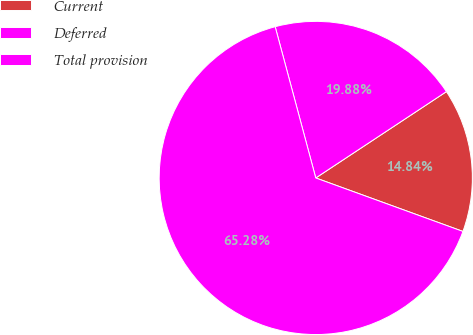Convert chart. <chart><loc_0><loc_0><loc_500><loc_500><pie_chart><fcel>Current<fcel>Deferred<fcel>Total provision<nl><fcel>14.84%<fcel>19.88%<fcel>65.28%<nl></chart> 